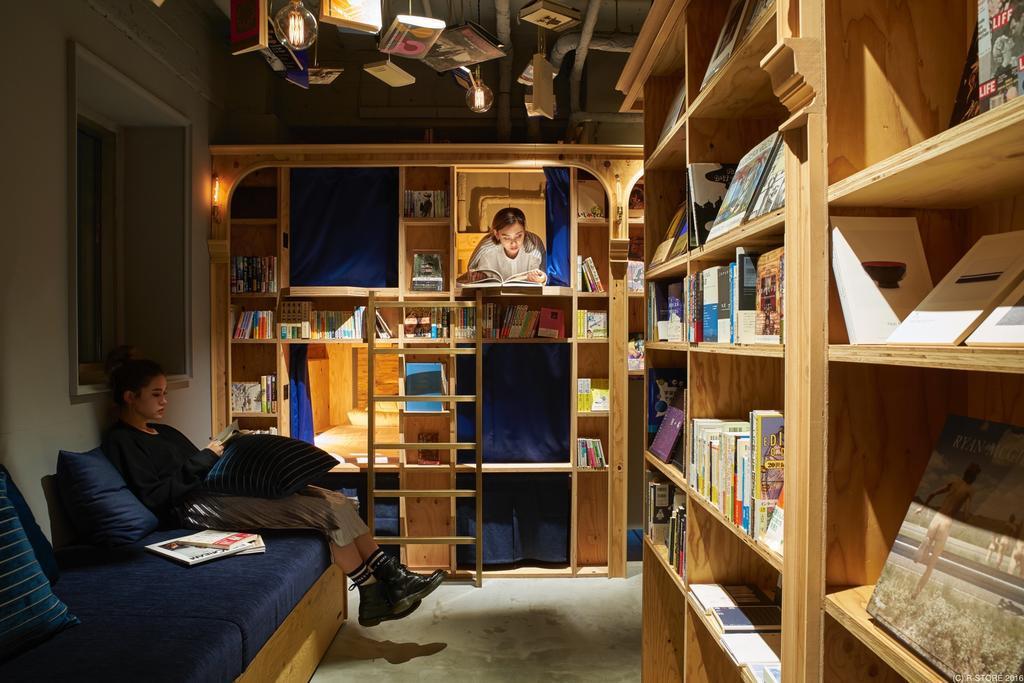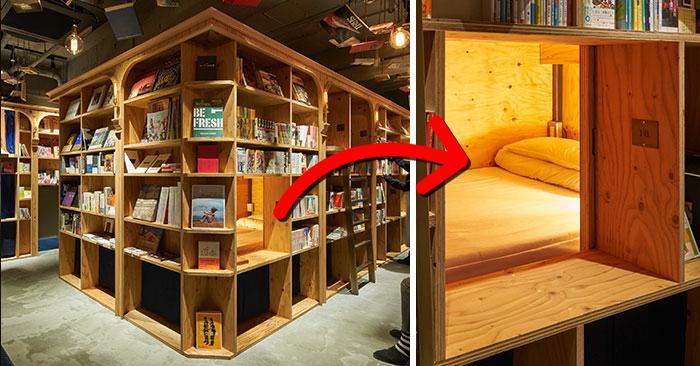The first image is the image on the left, the second image is the image on the right. Examine the images to the left and right. Is the description "A blue seating area sits near the books in the image on the right." accurate? Answer yes or no. No. The first image is the image on the left, the second image is the image on the right. Analyze the images presented: Is the assertion "In one scene, one person is sitting and reading on a blue cushioned bench in front of raw-wood shelves and near a ladder." valid? Answer yes or no. Yes. 